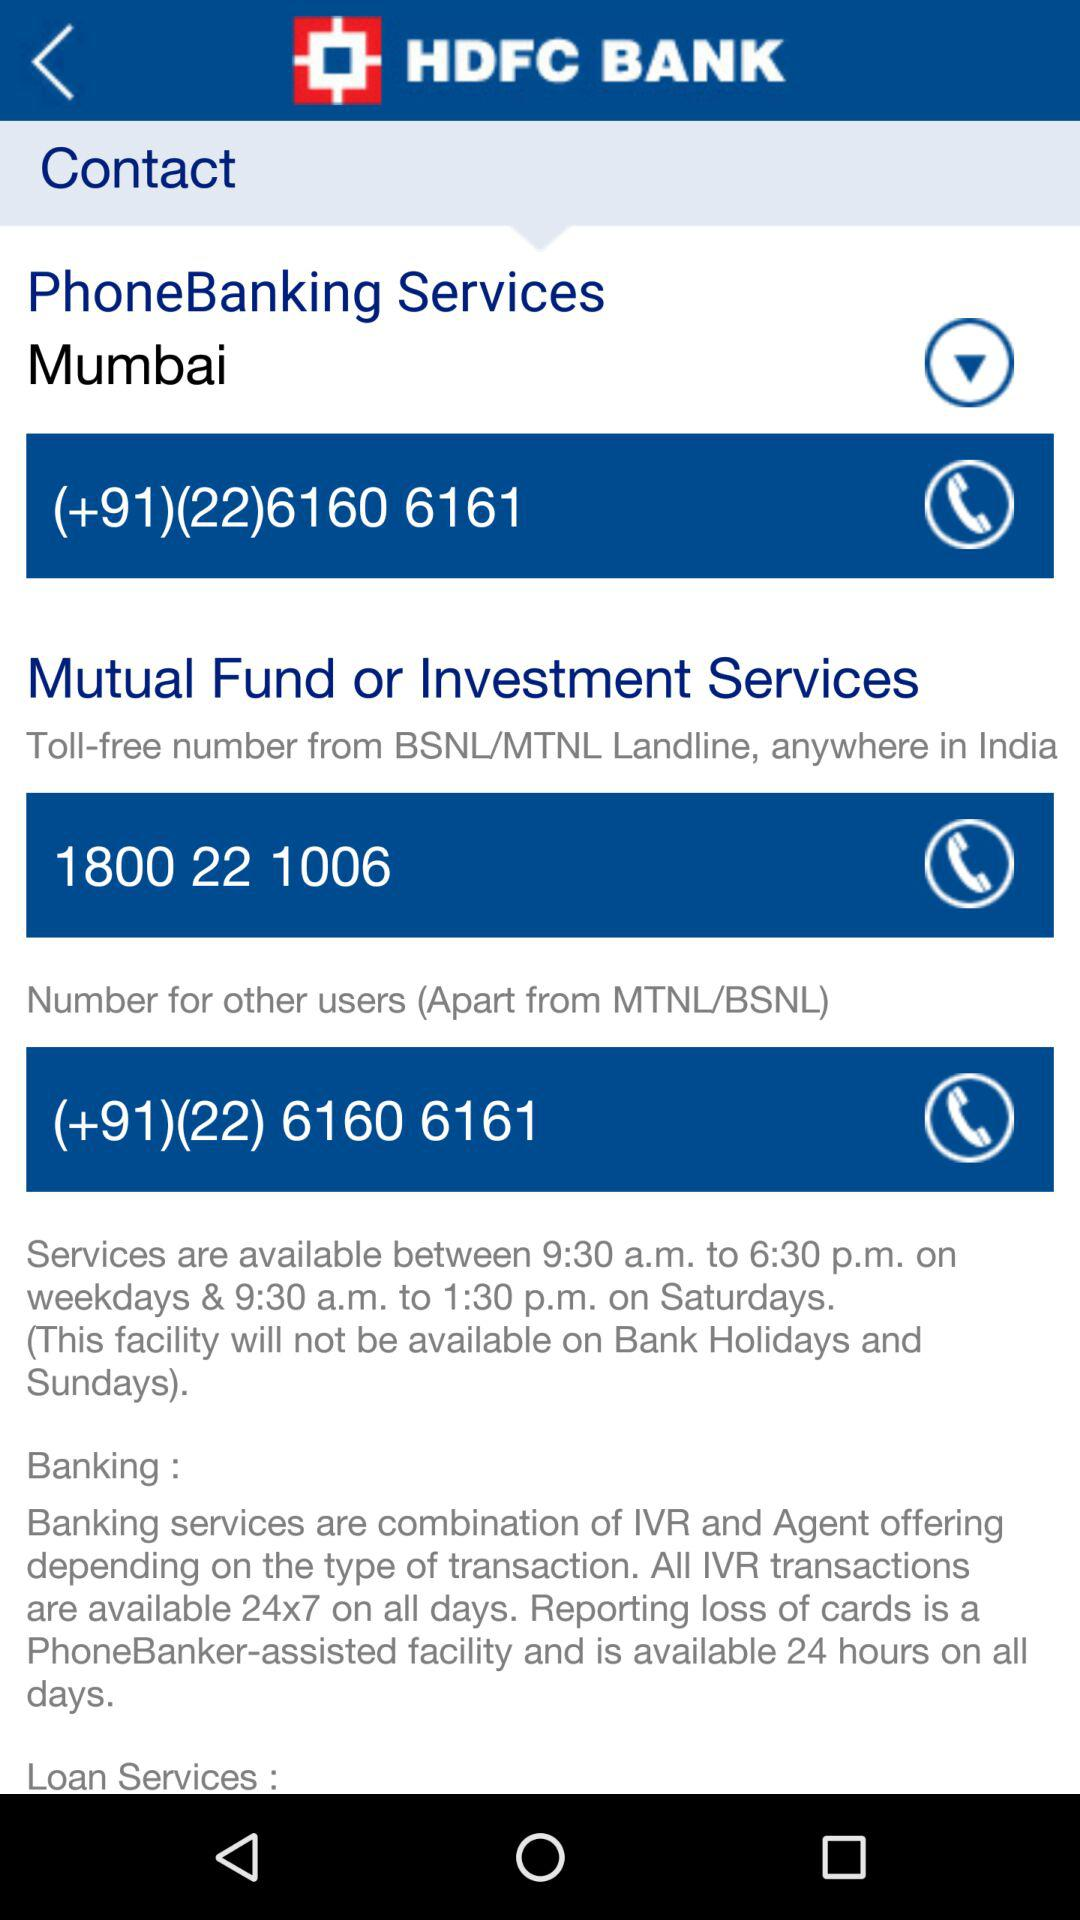What is the contact number for "Mutual Fund or Investment Services"? The contact numbers are 1800 22 1006 and (+91)(22) 6160 6161. 